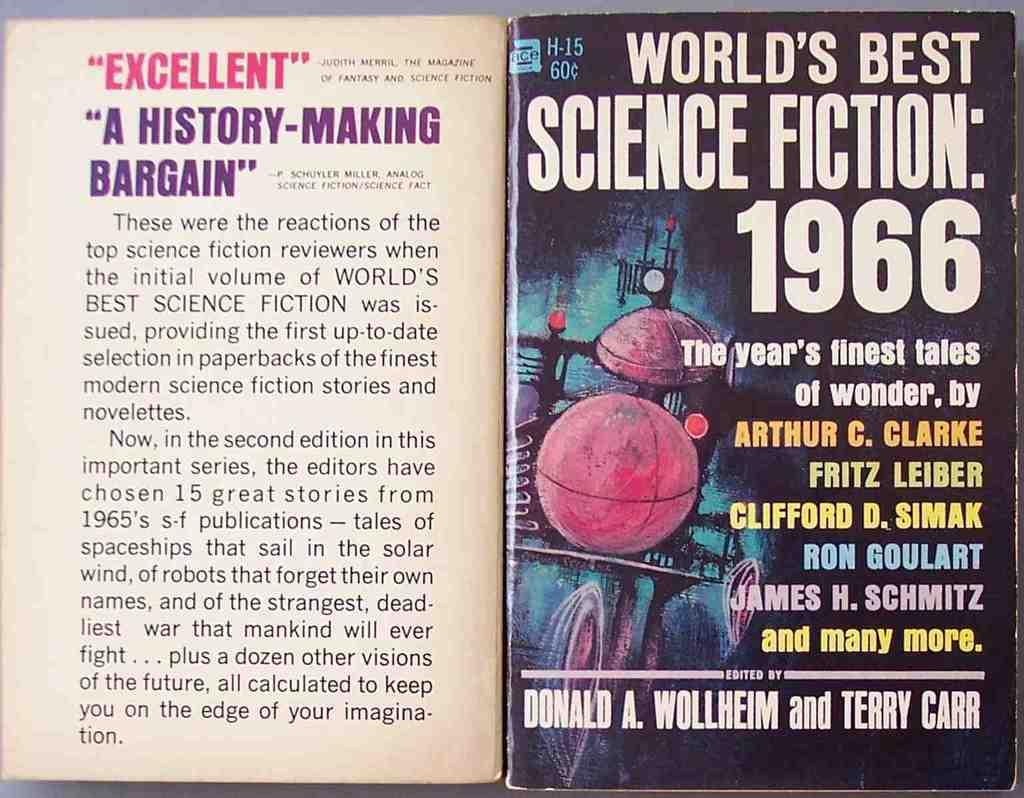<image>
Describe the image concisely. the cover of the book worlds best science fiction 1966. 